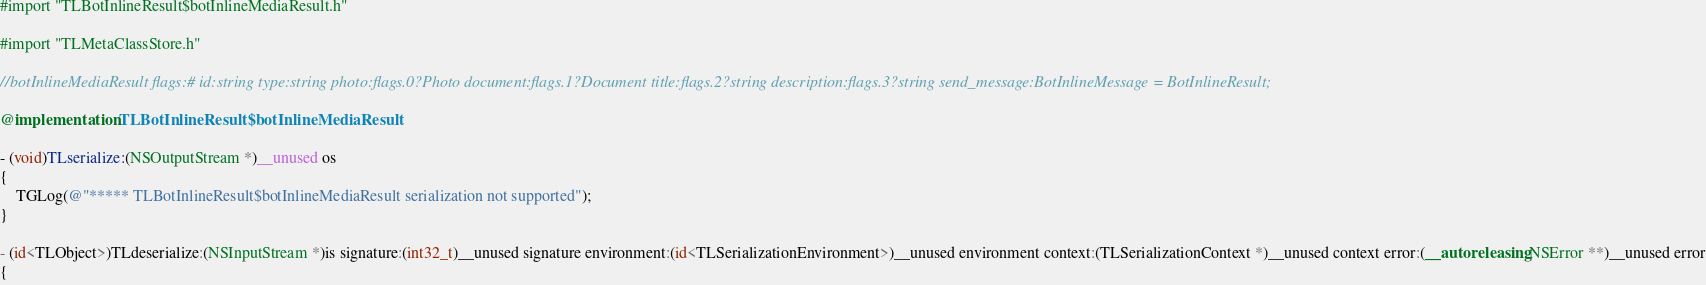<code> <loc_0><loc_0><loc_500><loc_500><_ObjectiveC_>#import "TLBotInlineResult$botInlineMediaResult.h"

#import "TLMetaClassStore.h"

//botInlineMediaResult flags:# id:string type:string photo:flags.0?Photo document:flags.1?Document title:flags.2?string description:flags.3?string send_message:BotInlineMessage = BotInlineResult;

@implementation TLBotInlineResult$botInlineMediaResult

- (void)TLserialize:(NSOutputStream *)__unused os
{
    TGLog(@"***** TLBotInlineResult$botInlineMediaResult serialization not supported");
}

- (id<TLObject>)TLdeserialize:(NSInputStream *)is signature:(int32_t)__unused signature environment:(id<TLSerializationEnvironment>)__unused environment context:(TLSerializationContext *)__unused context error:(__autoreleasing NSError **)__unused error
{</code> 